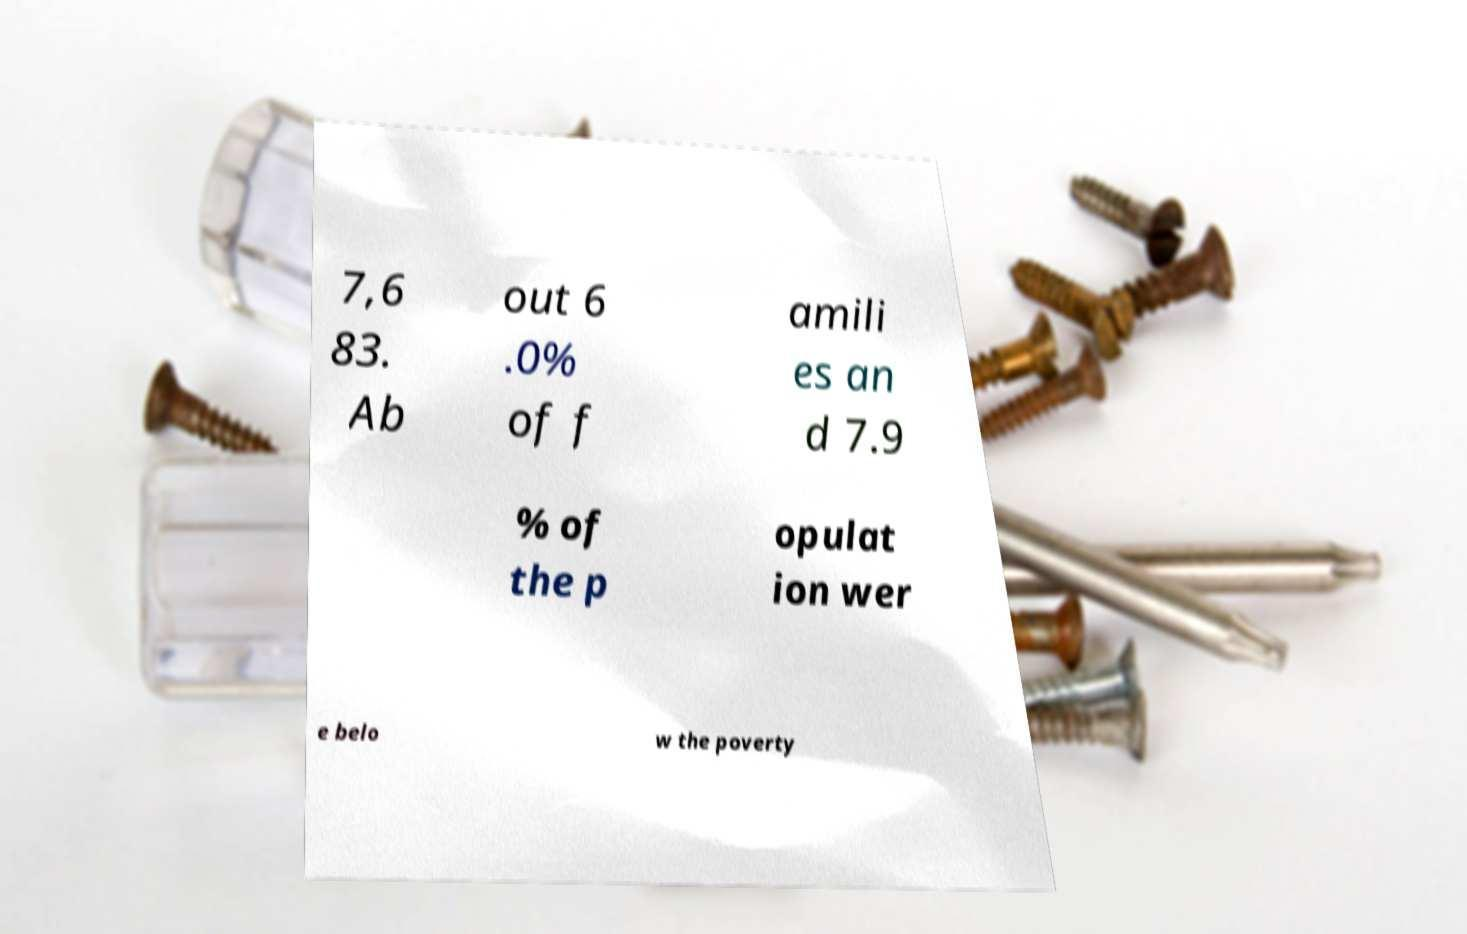Can you accurately transcribe the text from the provided image for me? 7,6 83. Ab out 6 .0% of f amili es an d 7.9 % of the p opulat ion wer e belo w the poverty 